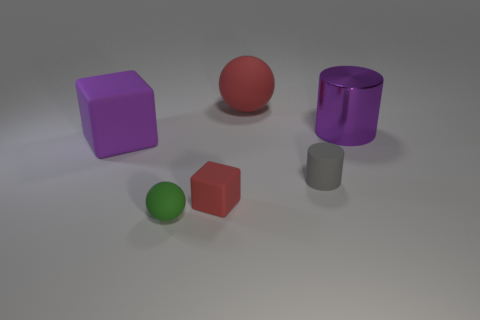Add 4 large red things. How many objects exist? 10 Subtract all balls. How many objects are left? 4 Subtract all small rubber spheres. Subtract all purple blocks. How many objects are left? 4 Add 1 red spheres. How many red spheres are left? 2 Add 5 green balls. How many green balls exist? 6 Subtract 0 brown cubes. How many objects are left? 6 